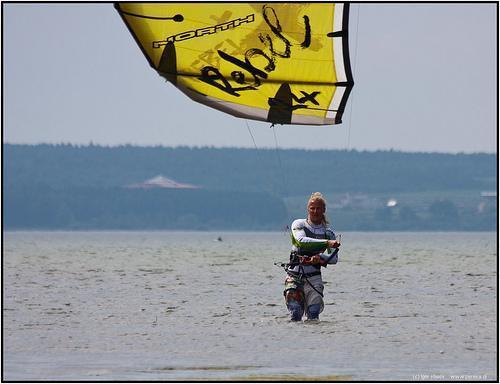How many layers of bananas on this tree have been almost totally picked?
Give a very brief answer. 0. 